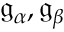Convert formula to latex. <formula><loc_0><loc_0><loc_500><loc_500>{ \mathfrak { g } } _ { \alpha } , { \mathfrak { g } } _ { \beta }</formula> 